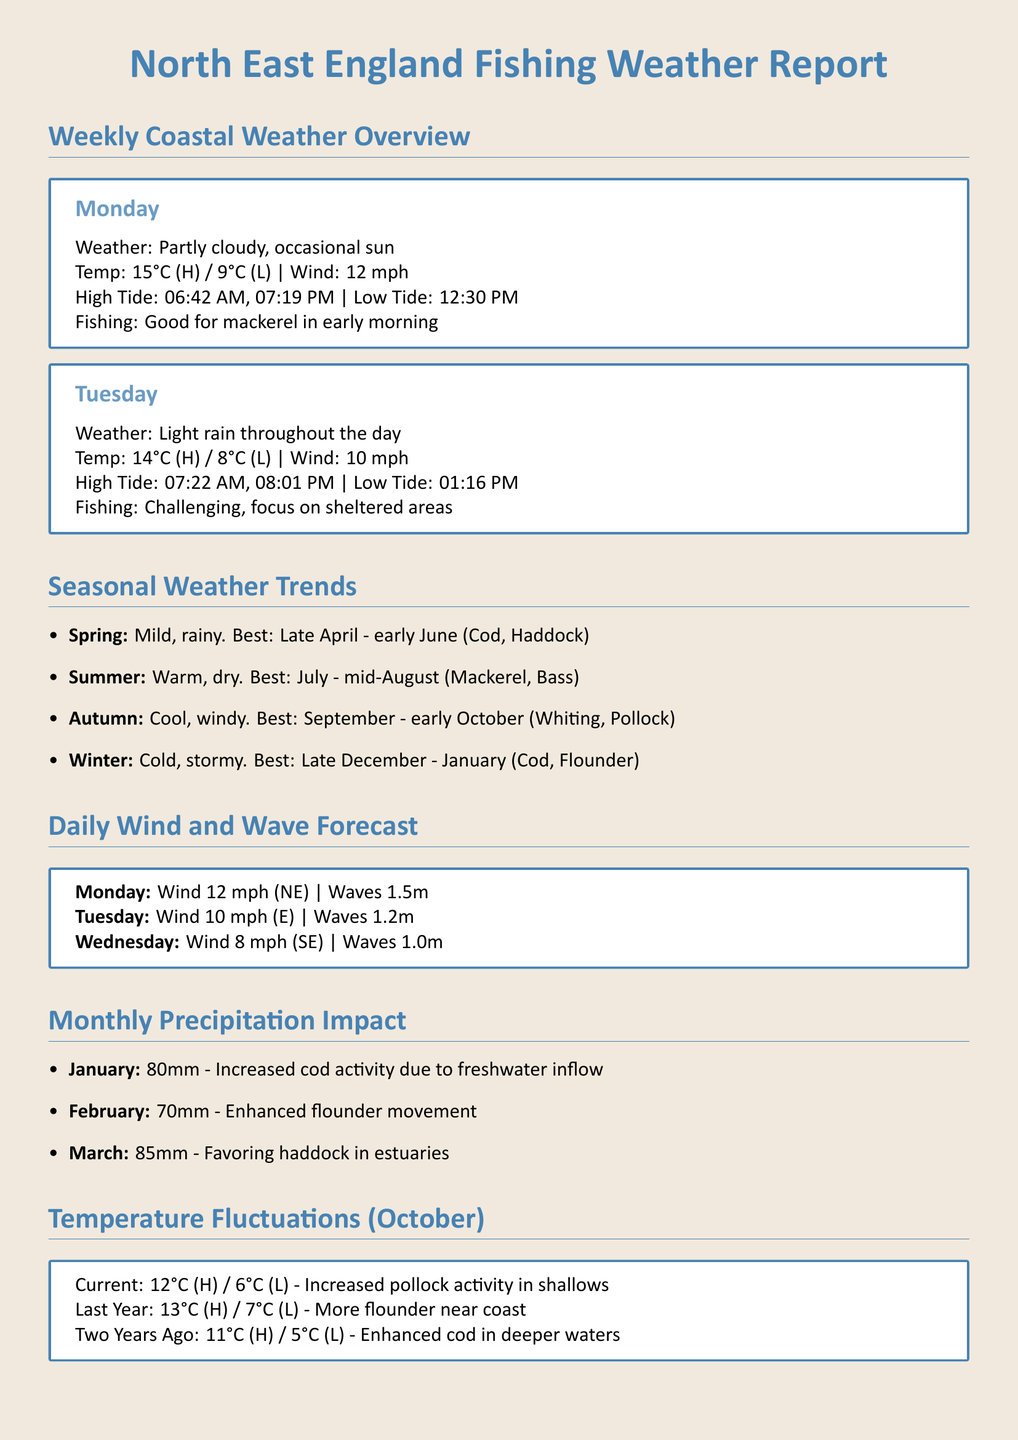What is the fishing condition for Monday? The fishing condition for Monday is indicated under the "Fishing" section for that day in the document.
Answer: Good for mackerel in early morning What is the high tide time on Tuesday? High tide time can be found in the "Weekly Coastal Weather Overview" section for Tuesday.
Answer: 07:22 AM What are the best fishing periods in summer? The best fishing periods in summer are specified in the "Seasonal Weather Trends" section.
Answer: July - mid-August (Mackerel, Bass) What is the wave height forecast for Monday? The wave height for Monday is mentioned in the "Daily Wind and Wave Forecast" section.
Answer: 1.5m How much precipitation was recorded in January? The precipitation for January is detailed in the "Monthly Precipitation Impact" section.
Answer: 80mm What is the current high temperature reported for October? The current high temperature for October is found in the "Temperature Fluctuations" section.
Answer: 12°C What fish species has increased activity due to current temperatures? The fish species' reaction to temperature fluctuations is noted in the "Temperature Fluctuations" section.
Answer: Pollock What wind speed is forecasted for Tuesday? The wind speed for Tuesday is located in the "Daily Wind and Wave Forecast" section.
Answer: 10 mph During which season is cod best caught? The best season for cod is mentioned in the "Seasonal Weather Trends."
Answer: Winter 